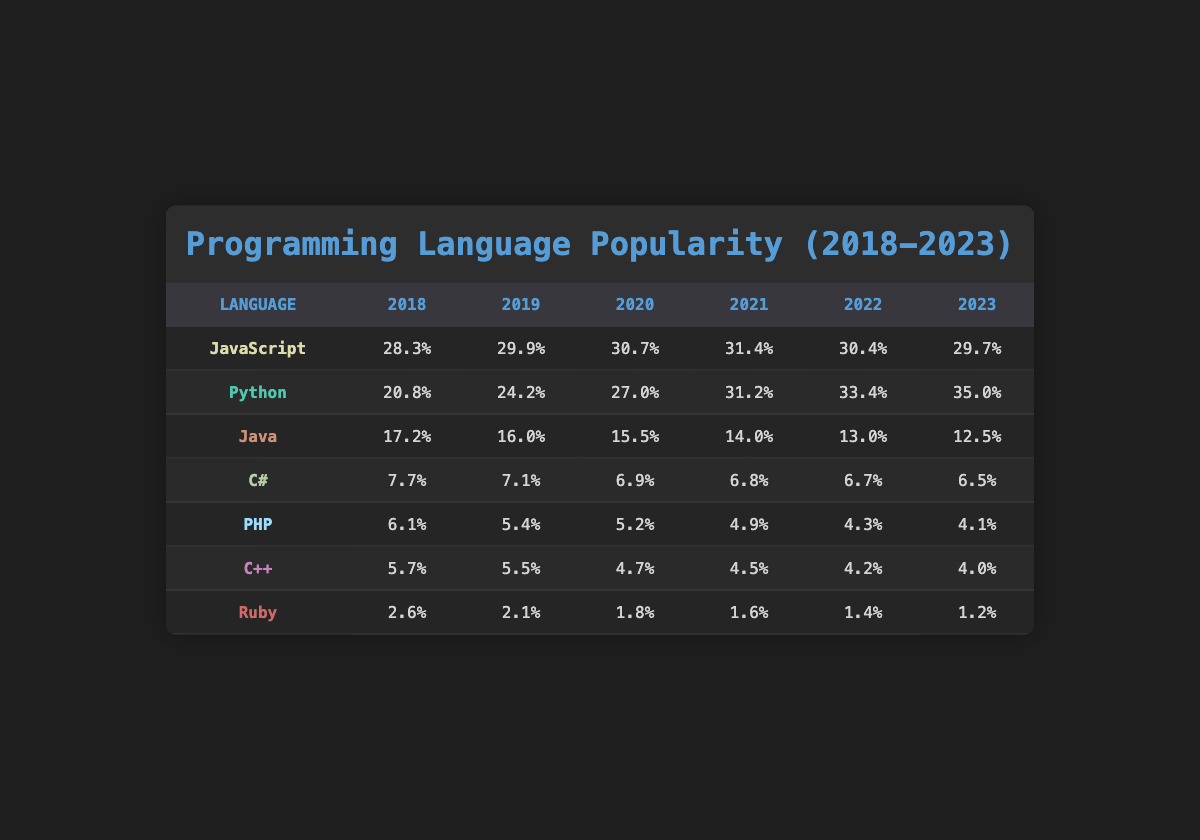What was the popularity percentage of Python in 2020? In the year 2020, you can find the row for Python and read its corresponding value in that year, which is listed as 27.0% in the table.
Answer: 27.0% Which language had the highest popularity in 2021? Looking at the 2021 column in the table, JavaScript has the highest percentage listed at 31.4%, compared to other languages that have lower values.
Answer: JavaScript What is the average popularity of Java from 2018 to 2023? To calculate the average popularity, sum up the percentages for Java over these years (17.2 + 16.0 + 15.5 + 14.0 + 13.0 + 12.5 = 88.2) and then divide by the number of years (6), so 88.2 / 6 = 14.7.
Answer: 14.7 Did C# ever exceed 8% popularity in any of the years listed? By reviewing the C# row across all years, C# has values of 7.7%, 7.1%, 6.9%, 6.8%, 6.7%, and 6.5%. All of these values are below 8%, indicating that C# did not exceed 8% in any year.
Answer: No In which year did Ruby see its highest popularity? By checking the Ruby row in the table, the highest popularity percentage is 2.6%, which is found in the year 2018; subsequent years all show lower values.
Answer: 2018 What was the difference in popularity between JavaScript in 2021 and Java in 2023? To find the difference, take the value for JavaScript in 2021 (31.4) and subtract the value for Java in 2023 (12.5). Therefore, the difference is 31.4 - 12.5 = 18.9.
Answer: 18.9 Has the popularity of Python consistently increased every year from 2018 to 2023? Checking the Python values from the years available: 20.8%, 24.2%, 27.0%, 31.2%, 33.4%, and 35.0%, we see that the popularity has increased each year without any decline.
Answer: Yes What was the total popularity percentage of all languages in 2022? To calculate the total, you sum the percentages for each language in 2022: 30.4 + 33.4 + 13.0 + 6.7 + 4.3 + 4.2 + 1.4 = 93.4.
Answer: 93.4 